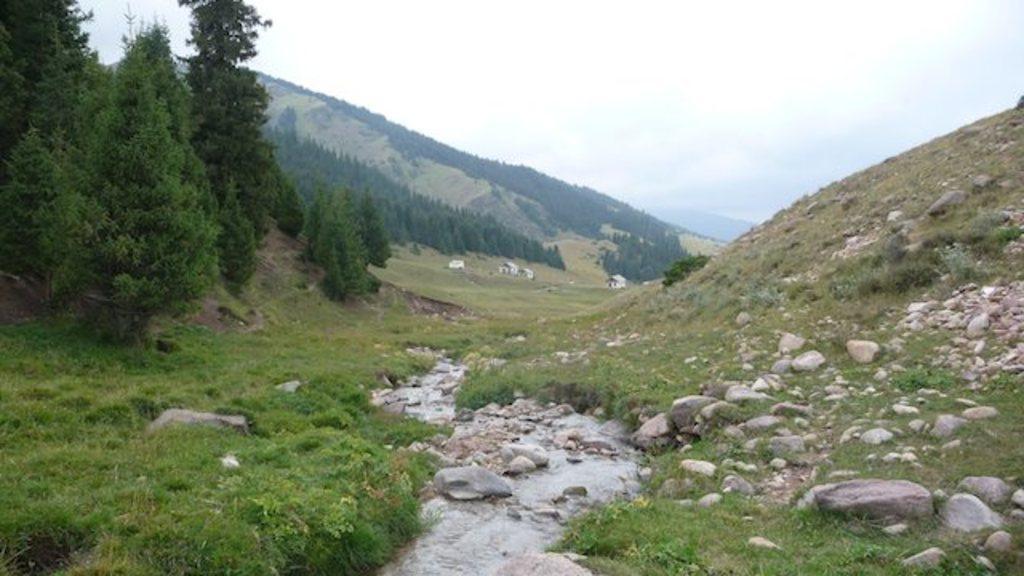Describe this image in one or two sentences. In this image at the bottom there is some water, and there is grass, rocks, stones, and trees. And in the background there are mountains and trees, at the top there is sky. 